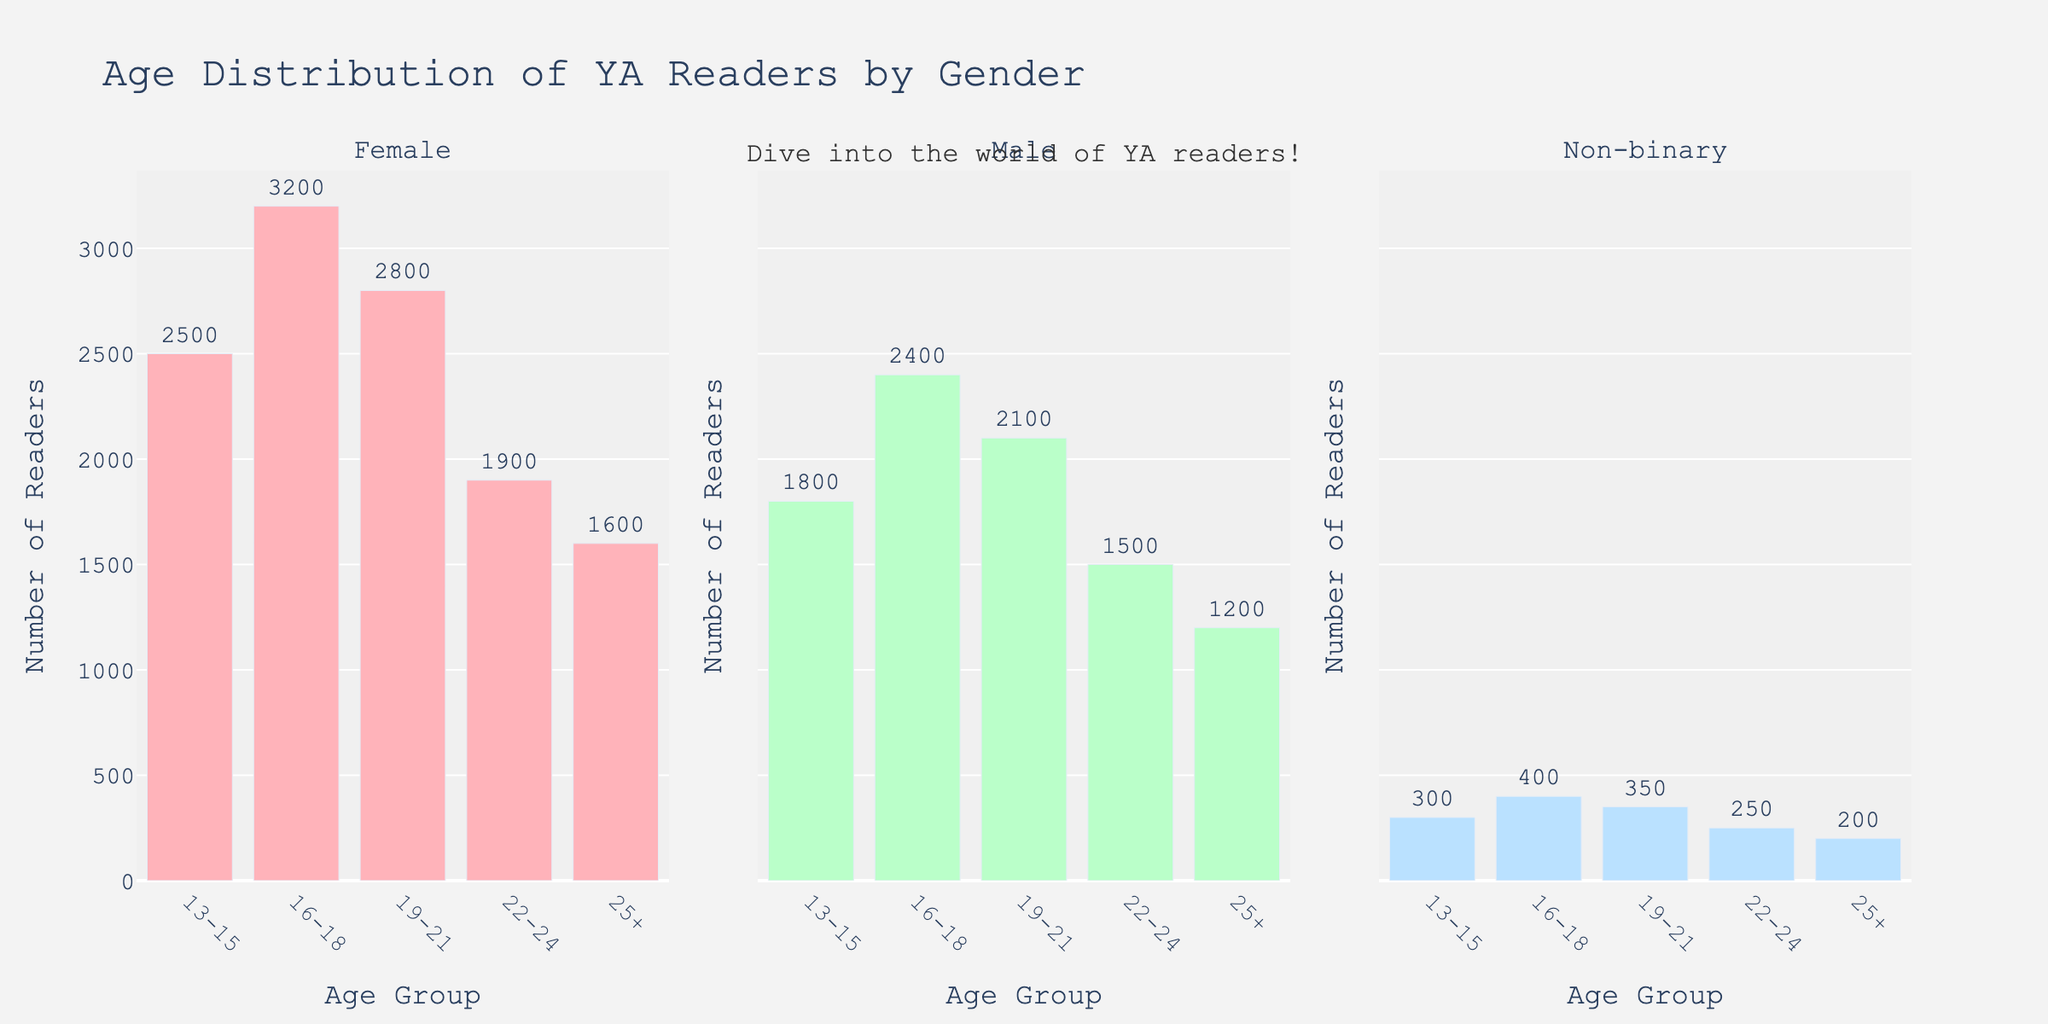What's the title of the plot? The title of the plot is located at the top center and usually states what the figure represents. In this case, it reads "Age Distribution of YA Readers by Gender".
Answer: Age Distribution of YA Readers by Gender What are the age groups displayed on the plot? The age groups are shown along the x-axis of each subplot. The groups are: 13-15, 16-18, 19-21, 22-24, and 25+.
Answer: 13-15, 16-18, 19-21, 22-24, 25+ Which gender has the highest number of readers in the 16-18 age group? By comparing the bars for the 16-18 age group in each subplot, observe the heights of the bars. The Female group has the highest bar for this age group.
Answer: Female What is the total number of readers in the 19-21 age group across all genders? Add the number of readers from each subplot for the 19-21 age group: Female (2800), Male (2100), and Non-binary (350). The total is 2800 + 2100 + 350.
Answer: 5250 How does the number of Male readers in the 22-24 age group compare to the number of Female readers in the same group? Look at the bars for the 22-24 age group in both the Male and Female subplots. Female readers are 1900 and Male readers are 1500. Calculate the difference: 1900 - 1500.
Answer: 400 more Female readers Which age group has the lowest number of Non-binary readers? Check the heights of the bars in the Non-binary subplot. The 25+ age group has the lowest number.
Answer: 25+ How many more Female readers are there than Male readers in the 13-15 age group? Subtract the number of Male readers (1800) from Female readers (2500) in the 13-15 age group: 2500 - 1800 = 700.
Answer: 700 In which subplot is the highest bar located and what is its value? Identify the tallest bar across all subplots. The tallest bar is in the Female subplot for the 16-18 age group with a value of 3200.
Answer: Female, 3200 What is the average number of readers in the 16-18 age group for all genders? Compute the average by adding the numbers from each gender (Female: 3200, Male: 2400, Non-binary: 400) and dividing by 3: (3200 + 2400 + 400) / 3 = 2000.
Answer: 2000 